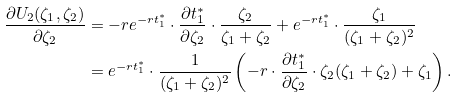<formula> <loc_0><loc_0><loc_500><loc_500>\frac { \partial U _ { 2 } ( \zeta _ { 1 } , \zeta _ { 2 } ) } { \partial \zeta _ { 2 } } & = - r e ^ { - r t _ { 1 } ^ { * } } \cdot \frac { \partial t _ { 1 } ^ { * } } { \partial \zeta _ { 2 } } \cdot \frac { \zeta _ { 2 } } { \zeta _ { 1 } + \zeta _ { 2 } } + e ^ { - r t _ { 1 } ^ { * } } \cdot \frac { \zeta _ { 1 } } { ( \zeta _ { 1 } + \zeta _ { 2 } ) ^ { 2 } } \\ & = e ^ { - r t _ { 1 } ^ { * } } \cdot \frac { 1 } { ( \zeta _ { 1 } + \zeta _ { 2 } ) ^ { 2 } } \left ( - r \cdot \frac { \partial t _ { 1 } ^ { * } } { \partial \zeta _ { 2 } } \cdot \zeta _ { 2 } ( \zeta _ { 1 } + \zeta _ { 2 } ) + \zeta _ { 1 } \right ) .</formula> 